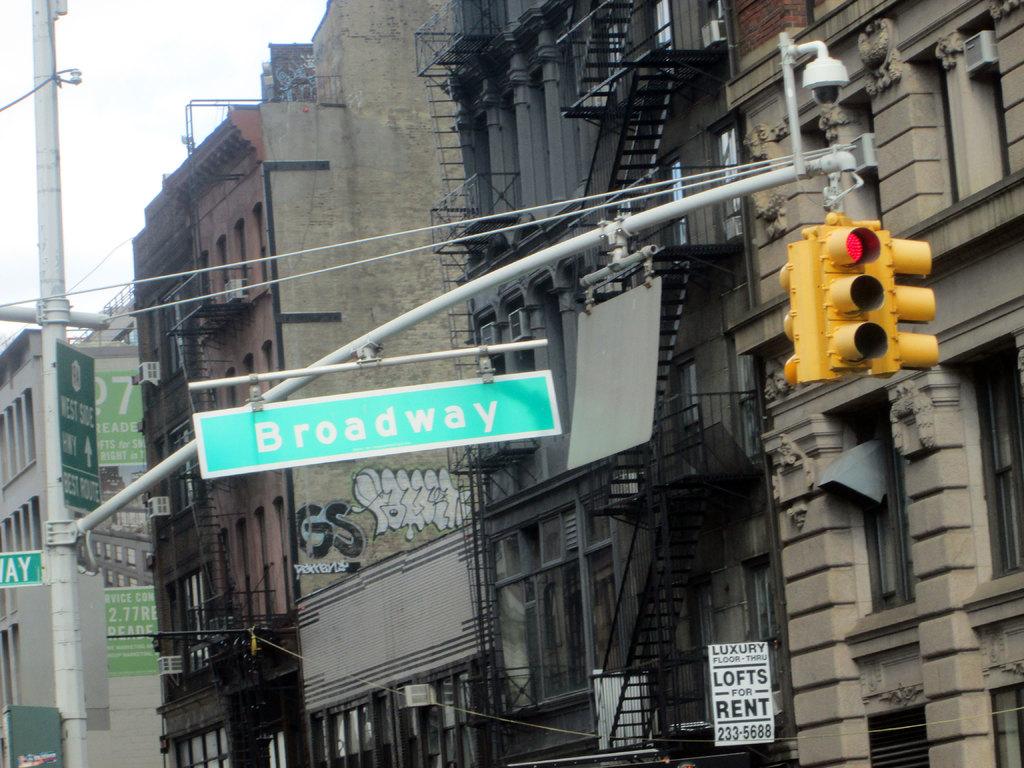What is for rent?
Make the answer very short. Lofts. 